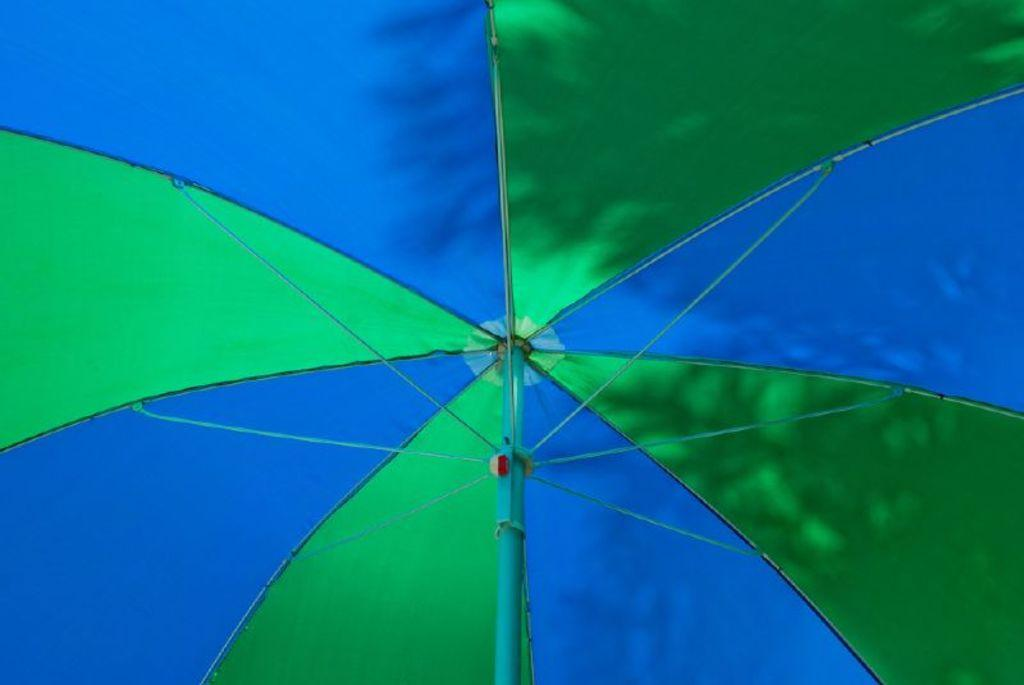What object can be seen in the picture? There is an umbrella in the picture. What colors are present on the umbrella? The umbrella has blue and green colors. Is there any shadow visible on the umbrella? Yes, there is a shadow of a tree on the umbrella. What grade did the ants receive on their recent test in the image? There are no ants or tests present in the image, so it is not possible to determine any grades. 